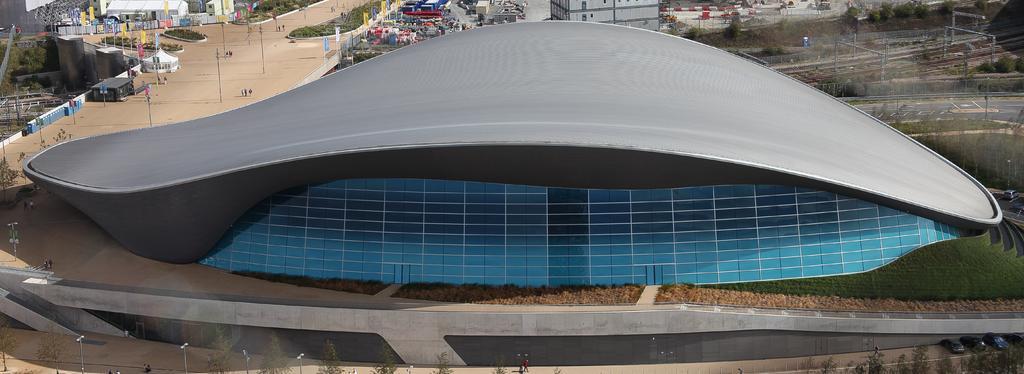Please provide a concise description of this image. In the foreground of the picture we can see trees, street lights, path, plants and a building. On the left there are street lights, road, people, trees, flags, construction and various objects. At the top we can see buildings, flags, plants and trees. On the right there are railway tracks, road, trees, cables, current poles and other objects. 